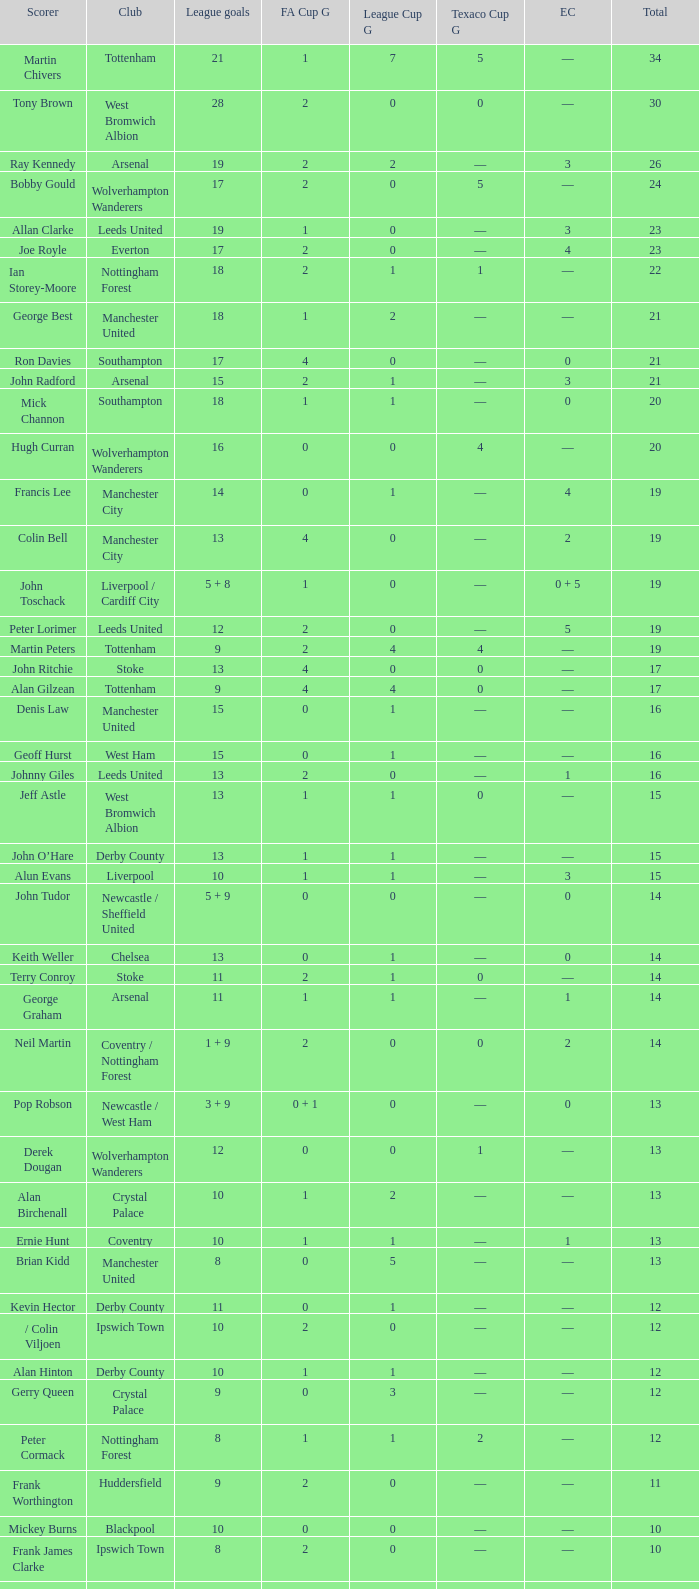What is the lowest League Cup Goals, when Scorer is Denis Law? 1.0. 